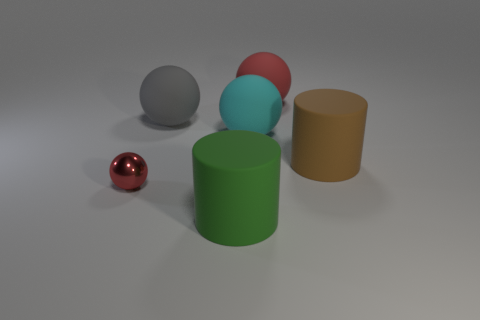Add 3 large cyan rubber balls. How many objects exist? 9 Subtract all balls. How many objects are left? 2 Subtract all small gray shiny cylinders. Subtract all large gray spheres. How many objects are left? 5 Add 5 large cyan rubber objects. How many large cyan rubber objects are left? 6 Add 1 big brown spheres. How many big brown spheres exist? 1 Subtract 0 red blocks. How many objects are left? 6 